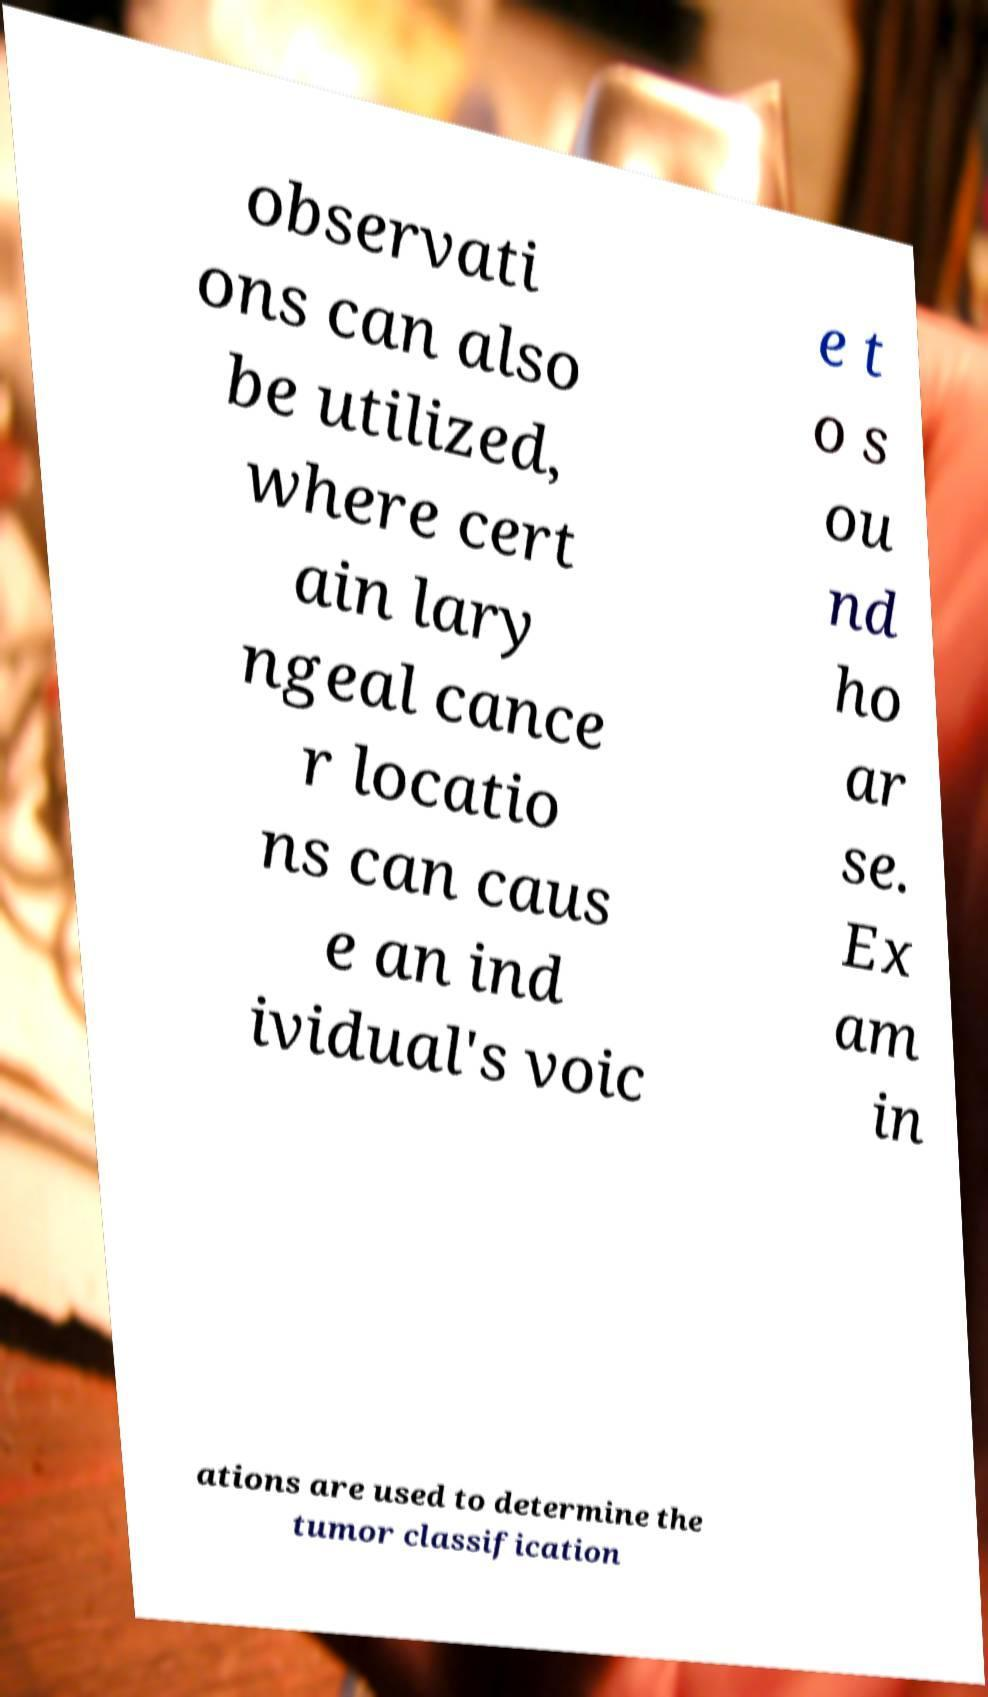Could you extract and type out the text from this image? observati ons can also be utilized, where cert ain lary ngeal cance r locatio ns can caus e an ind ividual's voic e t o s ou nd ho ar se. Ex am in ations are used to determine the tumor classification 